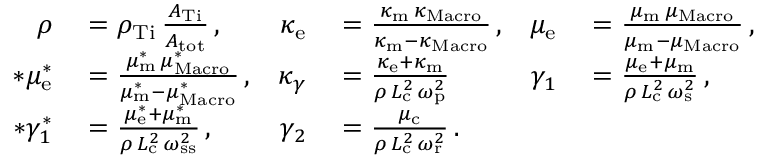Convert formula to latex. <formula><loc_0><loc_0><loc_500><loc_500>\begin{array} { r l r l r l } { \rho } & = \rho _ { T i } \, \frac { A _ { T i } } { A _ { t o t } } \, , } & { \kappa _ { e } } & = \frac { \kappa _ { m } \, \kappa _ { M a c r o } } { \kappa _ { m } - \kappa _ { M a c r o } } \, , } & { \mu _ { e } } & = \frac { \mu _ { m } \, \mu _ { M a c r o } } { \mu _ { m } - \mu _ { M a c r o } } \, , } \\ { * \mu _ { e } ^ { * } } & = \frac { \mu _ { m } ^ { * } \, \mu _ { M a c r o } ^ { * } } { \mu _ { m } ^ { * } - \mu _ { M a c r o } ^ { * } } \, , } & { \kappa _ { \gamma } } & = \frac { \kappa _ { e } + \kappa _ { m } } { \rho \, L _ { c } ^ { 2 } \, \omega _ { p } ^ { 2 } } } & { \gamma _ { 1 } } & = \frac { \mu _ { e } + \mu _ { m } } { \rho \, L _ { c } ^ { 2 } \, \omega _ { s } ^ { 2 } } \, , } \\ { * \gamma _ { 1 } ^ { * } } & = \frac { \mu _ { e } ^ { * } + \mu _ { m } ^ { * } } { \rho \, L _ { c } ^ { 2 } \, \omega _ { s s } ^ { 2 } } \, , } & { \gamma _ { 2 } } & = \frac { \mu _ { c } } { \rho \, L _ { c } ^ { 2 } \, \omega _ { r } ^ { 2 } } \, . } \end{array}</formula> 